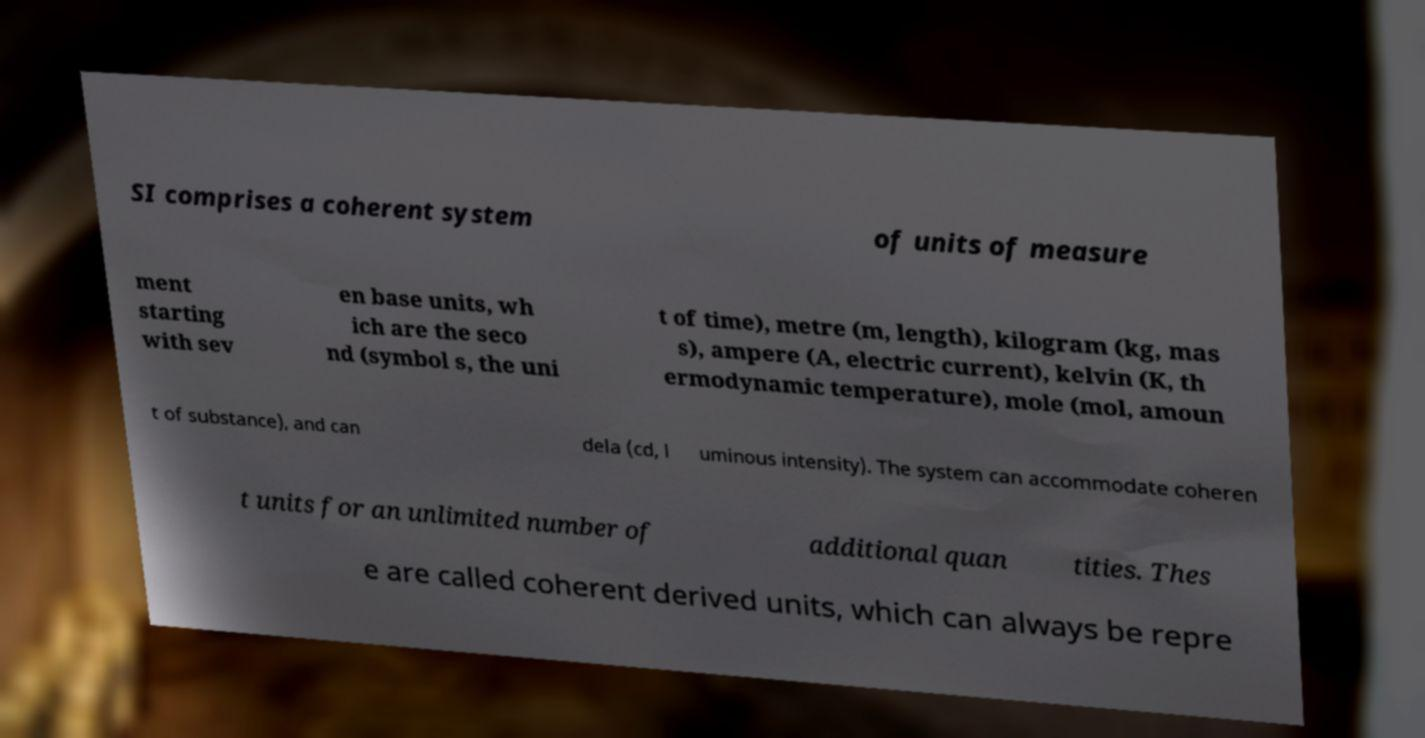I need the written content from this picture converted into text. Can you do that? SI comprises a coherent system of units of measure ment starting with sev en base units, wh ich are the seco nd (symbol s, the uni t of time), metre (m, length), kilogram (kg, mas s), ampere (A, electric current), kelvin (K, th ermodynamic temperature), mole (mol, amoun t of substance), and can dela (cd, l uminous intensity). The system can accommodate coheren t units for an unlimited number of additional quan tities. Thes e are called coherent derived units, which can always be repre 